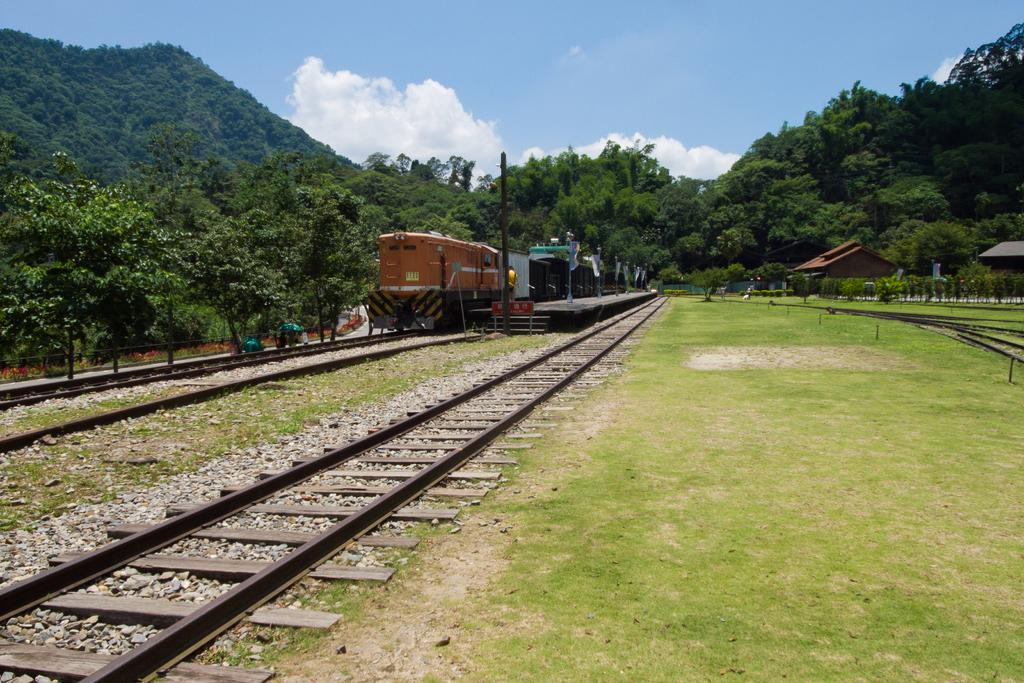What type of transportation infrastructure is visible in the image? There are railway tracks in the image. What is located on the railway tracks? A train is present on the railway tracks. What type of vegetation can be seen in the image? There is grass and trees visible in the image. What structure is present for passengers to board or disembark the train? There is a platform in the image. What is visible in the background of the image? Clouds and the sky are present in the background of the image. What type of birthday activity is taking place on the train in the image? There is no indication of a birthday activity taking place on the train in the image. Can you describe the group of people celebrating the birthday on the platform? There is no group of people celebrating a birthday present in the image. 